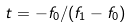Convert formula to latex. <formula><loc_0><loc_0><loc_500><loc_500>t = - f _ { 0 } / ( f _ { 1 } - f _ { 0 } )</formula> 